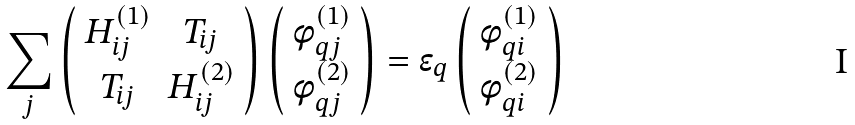Convert formula to latex. <formula><loc_0><loc_0><loc_500><loc_500>\sum _ { j } \left ( \begin{array} { c c c } { H } ^ { ( 1 ) } _ { i j } & { T } _ { i j } \\ { T } _ { i j } & { H } ^ { ( 2 ) } _ { i j } \\ \end{array} \right ) \left ( \begin{array} { c c c } { \phi } ^ { ( 1 ) } _ { q j } \\ { \phi } ^ { ( 2 ) } _ { q j } \\ \end{array} \right ) = \epsilon _ { q } \left ( \begin{array} { c c c } { \phi } ^ { ( 1 ) } _ { q i } \\ { \phi } ^ { ( 2 ) } _ { q i } \\ \end{array} \right )</formula> 